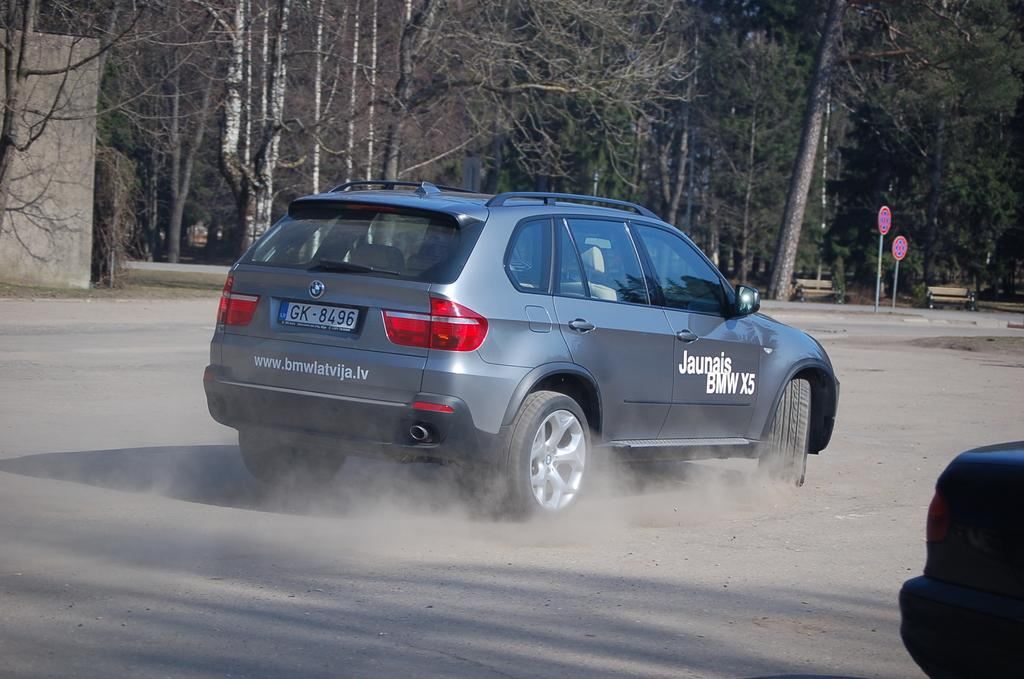Provide a one-sentence caption for the provided image. A car with smoking tires has a Jaunais BMW X5 written in white lettering on the side. 